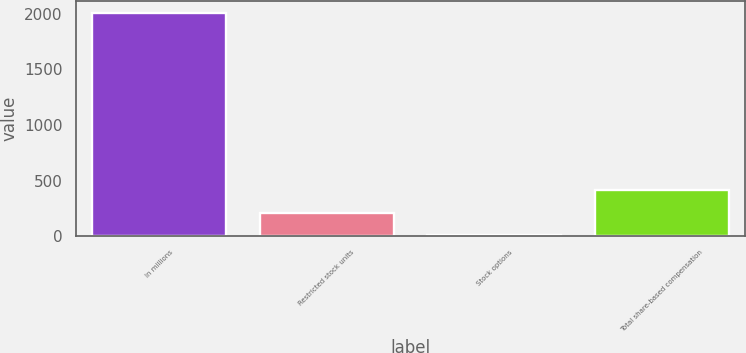<chart> <loc_0><loc_0><loc_500><loc_500><bar_chart><fcel>In millions<fcel>Restricted stock units<fcel>Stock options<fcel>Total share-based compensation<nl><fcel>2013<fcel>211.11<fcel>10.9<fcel>411.32<nl></chart> 